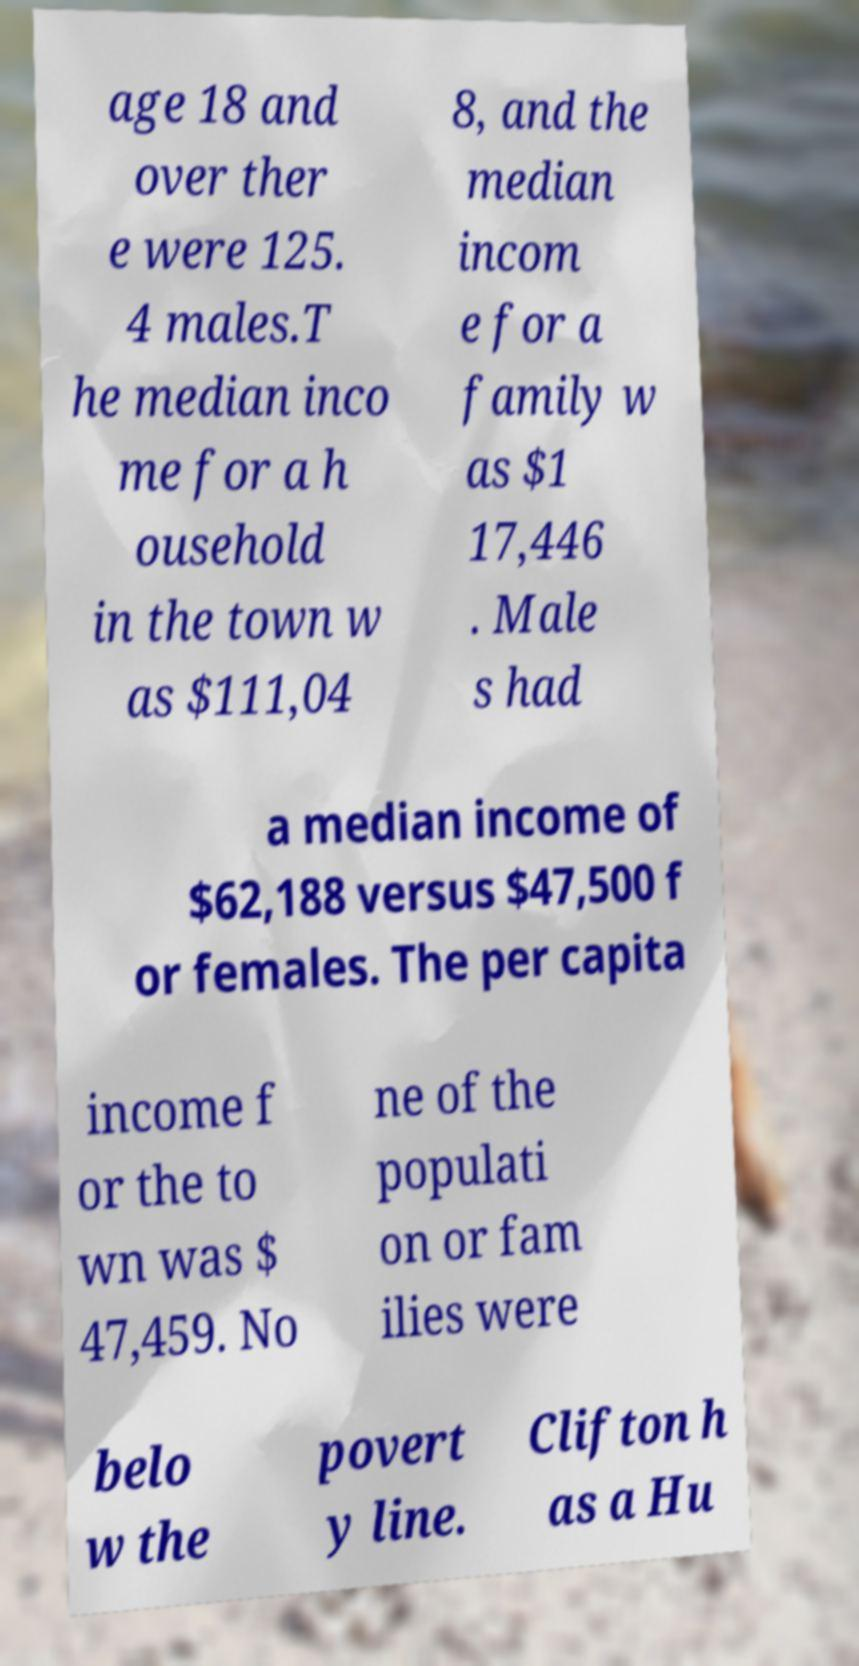Could you extract and type out the text from this image? age 18 and over ther e were 125. 4 males.T he median inco me for a h ousehold in the town w as $111,04 8, and the median incom e for a family w as $1 17,446 . Male s had a median income of $62,188 versus $47,500 f or females. The per capita income f or the to wn was $ 47,459. No ne of the populati on or fam ilies were belo w the povert y line. Clifton h as a Hu 